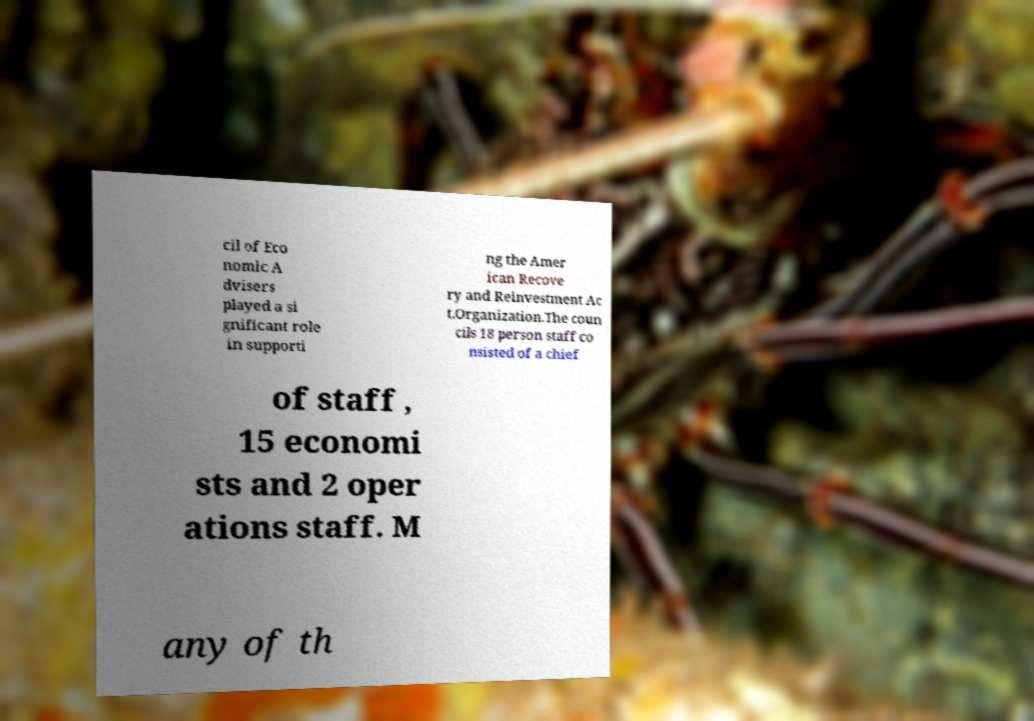There's text embedded in this image that I need extracted. Can you transcribe it verbatim? cil of Eco nomic A dvisers played a si gnificant role in supporti ng the Amer ican Recove ry and Reinvestment Ac t.Organization.The coun cils 18 person staff co nsisted of a chief of staff , 15 economi sts and 2 oper ations staff. M any of th 